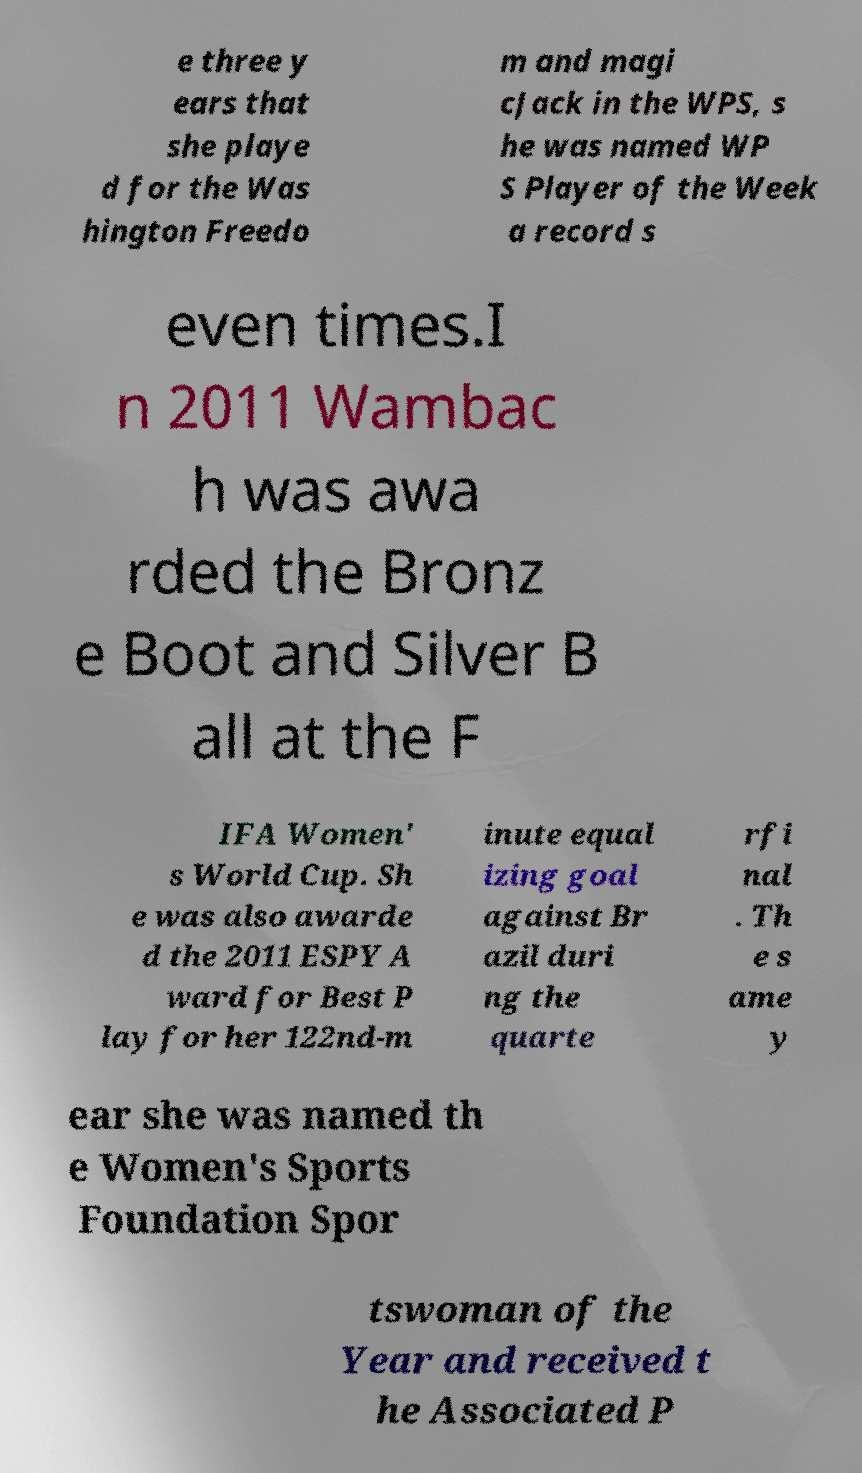Please identify and transcribe the text found in this image. e three y ears that she playe d for the Was hington Freedo m and magi cJack in the WPS, s he was named WP S Player of the Week a record s even times.I n 2011 Wambac h was awa rded the Bronz e Boot and Silver B all at the F IFA Women' s World Cup. Sh e was also awarde d the 2011 ESPY A ward for Best P lay for her 122nd-m inute equal izing goal against Br azil duri ng the quarte rfi nal . Th e s ame y ear she was named th e Women's Sports Foundation Spor tswoman of the Year and received t he Associated P 